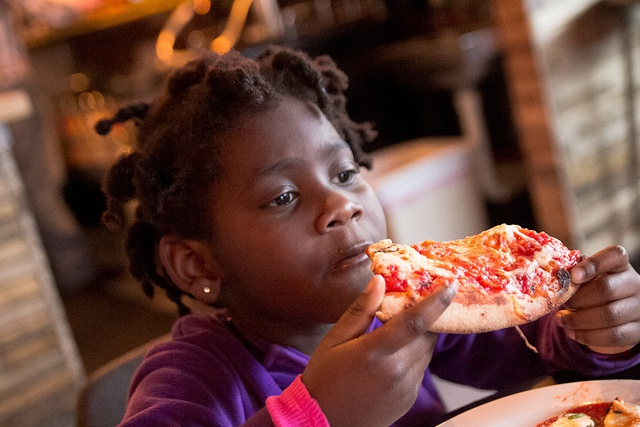Describe the objects in this image and their specific colors. I can see people in maroon, black, and brown tones, pizza in maroon, lightgray, salmon, and tan tones, and chair in maroon and black tones in this image. 